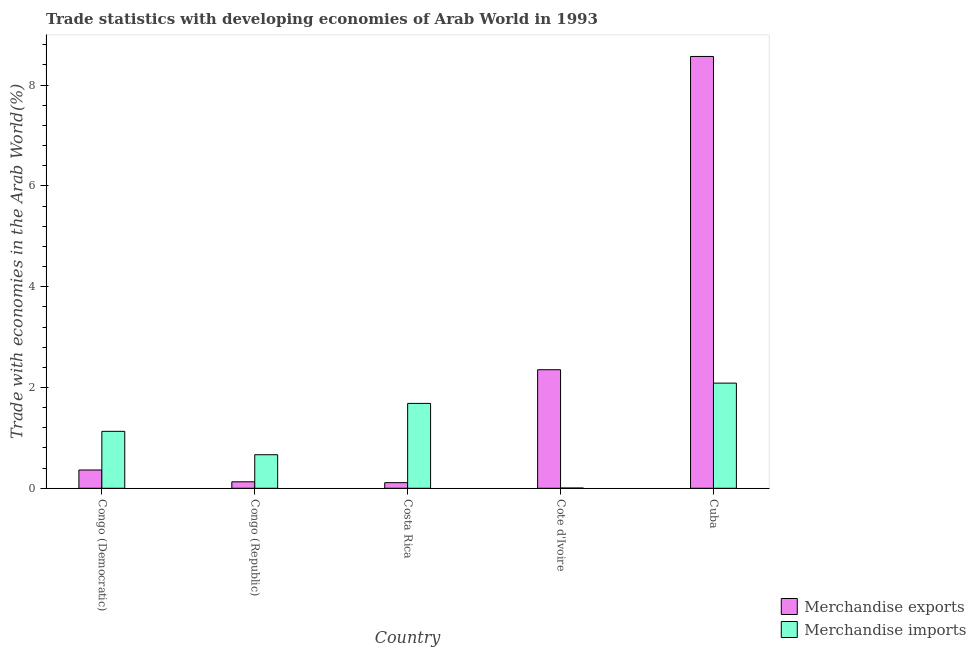How many different coloured bars are there?
Offer a terse response. 2. Are the number of bars per tick equal to the number of legend labels?
Provide a succinct answer. Yes. How many bars are there on the 4th tick from the left?
Make the answer very short. 2. What is the label of the 3rd group of bars from the left?
Offer a terse response. Costa Rica. In how many cases, is the number of bars for a given country not equal to the number of legend labels?
Offer a terse response. 0. What is the merchandise imports in Costa Rica?
Provide a succinct answer. 1.68. Across all countries, what is the maximum merchandise imports?
Offer a terse response. 2.09. Across all countries, what is the minimum merchandise imports?
Make the answer very short. 0.01. In which country was the merchandise exports maximum?
Ensure brevity in your answer.  Cuba. In which country was the merchandise imports minimum?
Your answer should be compact. Cote d'Ivoire. What is the total merchandise exports in the graph?
Your answer should be very brief. 11.52. What is the difference between the merchandise exports in Congo (Republic) and that in Cote d'Ivoire?
Your answer should be compact. -2.22. What is the difference between the merchandise exports in Cuba and the merchandise imports in Congo (Democratic)?
Your answer should be compact. 7.44. What is the average merchandise imports per country?
Provide a succinct answer. 1.11. What is the difference between the merchandise exports and merchandise imports in Costa Rica?
Provide a succinct answer. -1.57. In how many countries, is the merchandise imports greater than 6.8 %?
Make the answer very short. 0. What is the ratio of the merchandise exports in Congo (Democratic) to that in Cuba?
Provide a succinct answer. 0.04. Is the merchandise exports in Cote d'Ivoire less than that in Cuba?
Provide a succinct answer. Yes. Is the difference between the merchandise imports in Cote d'Ivoire and Cuba greater than the difference between the merchandise exports in Cote d'Ivoire and Cuba?
Give a very brief answer. Yes. What is the difference between the highest and the second highest merchandise imports?
Give a very brief answer. 0.4. What is the difference between the highest and the lowest merchandise exports?
Give a very brief answer. 8.46. In how many countries, is the merchandise exports greater than the average merchandise exports taken over all countries?
Ensure brevity in your answer.  2. Is the sum of the merchandise exports in Congo (Democratic) and Congo (Republic) greater than the maximum merchandise imports across all countries?
Ensure brevity in your answer.  No. What does the 2nd bar from the left in Congo (Democratic) represents?
Your response must be concise. Merchandise imports. How many countries are there in the graph?
Keep it short and to the point. 5. Does the graph contain grids?
Ensure brevity in your answer.  No. How many legend labels are there?
Offer a terse response. 2. What is the title of the graph?
Offer a very short reply. Trade statistics with developing economies of Arab World in 1993. What is the label or title of the X-axis?
Provide a succinct answer. Country. What is the label or title of the Y-axis?
Give a very brief answer. Trade with economies in the Arab World(%). What is the Trade with economies in the Arab World(%) of Merchandise exports in Congo (Democratic)?
Offer a terse response. 0.36. What is the Trade with economies in the Arab World(%) of Merchandise imports in Congo (Democratic)?
Keep it short and to the point. 1.13. What is the Trade with economies in the Arab World(%) of Merchandise exports in Congo (Republic)?
Ensure brevity in your answer.  0.13. What is the Trade with economies in the Arab World(%) in Merchandise imports in Congo (Republic)?
Provide a short and direct response. 0.67. What is the Trade with economies in the Arab World(%) in Merchandise exports in Costa Rica?
Offer a terse response. 0.11. What is the Trade with economies in the Arab World(%) of Merchandise imports in Costa Rica?
Keep it short and to the point. 1.68. What is the Trade with economies in the Arab World(%) of Merchandise exports in Cote d'Ivoire?
Your answer should be compact. 2.35. What is the Trade with economies in the Arab World(%) of Merchandise imports in Cote d'Ivoire?
Provide a short and direct response. 0.01. What is the Trade with economies in the Arab World(%) in Merchandise exports in Cuba?
Make the answer very short. 8.57. What is the Trade with economies in the Arab World(%) of Merchandise imports in Cuba?
Provide a succinct answer. 2.09. Across all countries, what is the maximum Trade with economies in the Arab World(%) of Merchandise exports?
Your answer should be compact. 8.57. Across all countries, what is the maximum Trade with economies in the Arab World(%) of Merchandise imports?
Ensure brevity in your answer.  2.09. Across all countries, what is the minimum Trade with economies in the Arab World(%) in Merchandise exports?
Your answer should be compact. 0.11. Across all countries, what is the minimum Trade with economies in the Arab World(%) of Merchandise imports?
Your response must be concise. 0.01. What is the total Trade with economies in the Arab World(%) of Merchandise exports in the graph?
Make the answer very short. 11.52. What is the total Trade with economies in the Arab World(%) of Merchandise imports in the graph?
Give a very brief answer. 5.57. What is the difference between the Trade with economies in the Arab World(%) in Merchandise exports in Congo (Democratic) and that in Congo (Republic)?
Offer a very short reply. 0.23. What is the difference between the Trade with economies in the Arab World(%) of Merchandise imports in Congo (Democratic) and that in Congo (Republic)?
Your response must be concise. 0.46. What is the difference between the Trade with economies in the Arab World(%) in Merchandise exports in Congo (Democratic) and that in Costa Rica?
Your answer should be very brief. 0.25. What is the difference between the Trade with economies in the Arab World(%) in Merchandise imports in Congo (Democratic) and that in Costa Rica?
Offer a very short reply. -0.55. What is the difference between the Trade with economies in the Arab World(%) in Merchandise exports in Congo (Democratic) and that in Cote d'Ivoire?
Your answer should be very brief. -1.99. What is the difference between the Trade with economies in the Arab World(%) in Merchandise imports in Congo (Democratic) and that in Cote d'Ivoire?
Your response must be concise. 1.12. What is the difference between the Trade with economies in the Arab World(%) of Merchandise exports in Congo (Democratic) and that in Cuba?
Provide a short and direct response. -8.2. What is the difference between the Trade with economies in the Arab World(%) in Merchandise imports in Congo (Democratic) and that in Cuba?
Ensure brevity in your answer.  -0.96. What is the difference between the Trade with economies in the Arab World(%) in Merchandise exports in Congo (Republic) and that in Costa Rica?
Your response must be concise. 0.02. What is the difference between the Trade with economies in the Arab World(%) of Merchandise imports in Congo (Republic) and that in Costa Rica?
Offer a very short reply. -1.02. What is the difference between the Trade with economies in the Arab World(%) of Merchandise exports in Congo (Republic) and that in Cote d'Ivoire?
Your response must be concise. -2.22. What is the difference between the Trade with economies in the Arab World(%) of Merchandise imports in Congo (Republic) and that in Cote d'Ivoire?
Your answer should be very brief. 0.66. What is the difference between the Trade with economies in the Arab World(%) in Merchandise exports in Congo (Republic) and that in Cuba?
Provide a short and direct response. -8.44. What is the difference between the Trade with economies in the Arab World(%) of Merchandise imports in Congo (Republic) and that in Cuba?
Give a very brief answer. -1.42. What is the difference between the Trade with economies in the Arab World(%) in Merchandise exports in Costa Rica and that in Cote d'Ivoire?
Provide a succinct answer. -2.24. What is the difference between the Trade with economies in the Arab World(%) of Merchandise imports in Costa Rica and that in Cote d'Ivoire?
Provide a succinct answer. 1.68. What is the difference between the Trade with economies in the Arab World(%) of Merchandise exports in Costa Rica and that in Cuba?
Ensure brevity in your answer.  -8.46. What is the difference between the Trade with economies in the Arab World(%) of Merchandise imports in Costa Rica and that in Cuba?
Keep it short and to the point. -0.4. What is the difference between the Trade with economies in the Arab World(%) in Merchandise exports in Cote d'Ivoire and that in Cuba?
Provide a short and direct response. -6.22. What is the difference between the Trade with economies in the Arab World(%) of Merchandise imports in Cote d'Ivoire and that in Cuba?
Provide a short and direct response. -2.08. What is the difference between the Trade with economies in the Arab World(%) of Merchandise exports in Congo (Democratic) and the Trade with economies in the Arab World(%) of Merchandise imports in Congo (Republic)?
Keep it short and to the point. -0.3. What is the difference between the Trade with economies in the Arab World(%) in Merchandise exports in Congo (Democratic) and the Trade with economies in the Arab World(%) in Merchandise imports in Costa Rica?
Provide a succinct answer. -1.32. What is the difference between the Trade with economies in the Arab World(%) of Merchandise exports in Congo (Democratic) and the Trade with economies in the Arab World(%) of Merchandise imports in Cote d'Ivoire?
Provide a short and direct response. 0.36. What is the difference between the Trade with economies in the Arab World(%) in Merchandise exports in Congo (Democratic) and the Trade with economies in the Arab World(%) in Merchandise imports in Cuba?
Keep it short and to the point. -1.72. What is the difference between the Trade with economies in the Arab World(%) in Merchandise exports in Congo (Republic) and the Trade with economies in the Arab World(%) in Merchandise imports in Costa Rica?
Give a very brief answer. -1.56. What is the difference between the Trade with economies in the Arab World(%) of Merchandise exports in Congo (Republic) and the Trade with economies in the Arab World(%) of Merchandise imports in Cote d'Ivoire?
Ensure brevity in your answer.  0.12. What is the difference between the Trade with economies in the Arab World(%) of Merchandise exports in Congo (Republic) and the Trade with economies in the Arab World(%) of Merchandise imports in Cuba?
Your response must be concise. -1.96. What is the difference between the Trade with economies in the Arab World(%) of Merchandise exports in Costa Rica and the Trade with economies in the Arab World(%) of Merchandise imports in Cote d'Ivoire?
Ensure brevity in your answer.  0.11. What is the difference between the Trade with economies in the Arab World(%) of Merchandise exports in Costa Rica and the Trade with economies in the Arab World(%) of Merchandise imports in Cuba?
Offer a terse response. -1.98. What is the difference between the Trade with economies in the Arab World(%) in Merchandise exports in Cote d'Ivoire and the Trade with economies in the Arab World(%) in Merchandise imports in Cuba?
Ensure brevity in your answer.  0.27. What is the average Trade with economies in the Arab World(%) of Merchandise exports per country?
Your answer should be compact. 2.3. What is the average Trade with economies in the Arab World(%) in Merchandise imports per country?
Make the answer very short. 1.11. What is the difference between the Trade with economies in the Arab World(%) in Merchandise exports and Trade with economies in the Arab World(%) in Merchandise imports in Congo (Democratic)?
Offer a terse response. -0.77. What is the difference between the Trade with economies in the Arab World(%) of Merchandise exports and Trade with economies in the Arab World(%) of Merchandise imports in Congo (Republic)?
Your answer should be very brief. -0.54. What is the difference between the Trade with economies in the Arab World(%) in Merchandise exports and Trade with economies in the Arab World(%) in Merchandise imports in Costa Rica?
Offer a terse response. -1.57. What is the difference between the Trade with economies in the Arab World(%) of Merchandise exports and Trade with economies in the Arab World(%) of Merchandise imports in Cote d'Ivoire?
Provide a succinct answer. 2.35. What is the difference between the Trade with economies in the Arab World(%) of Merchandise exports and Trade with economies in the Arab World(%) of Merchandise imports in Cuba?
Your answer should be compact. 6.48. What is the ratio of the Trade with economies in the Arab World(%) in Merchandise exports in Congo (Democratic) to that in Congo (Republic)?
Make the answer very short. 2.82. What is the ratio of the Trade with economies in the Arab World(%) of Merchandise imports in Congo (Democratic) to that in Congo (Republic)?
Your answer should be compact. 1.7. What is the ratio of the Trade with economies in the Arab World(%) in Merchandise exports in Congo (Democratic) to that in Costa Rica?
Keep it short and to the point. 3.26. What is the ratio of the Trade with economies in the Arab World(%) in Merchandise imports in Congo (Democratic) to that in Costa Rica?
Give a very brief answer. 0.67. What is the ratio of the Trade with economies in the Arab World(%) of Merchandise exports in Congo (Democratic) to that in Cote d'Ivoire?
Provide a short and direct response. 0.15. What is the ratio of the Trade with economies in the Arab World(%) of Merchandise imports in Congo (Democratic) to that in Cote d'Ivoire?
Ensure brevity in your answer.  218.74. What is the ratio of the Trade with economies in the Arab World(%) in Merchandise exports in Congo (Democratic) to that in Cuba?
Ensure brevity in your answer.  0.04. What is the ratio of the Trade with economies in the Arab World(%) of Merchandise imports in Congo (Democratic) to that in Cuba?
Provide a short and direct response. 0.54. What is the ratio of the Trade with economies in the Arab World(%) in Merchandise exports in Congo (Republic) to that in Costa Rica?
Your response must be concise. 1.16. What is the ratio of the Trade with economies in the Arab World(%) in Merchandise imports in Congo (Republic) to that in Costa Rica?
Offer a very short reply. 0.4. What is the ratio of the Trade with economies in the Arab World(%) in Merchandise exports in Congo (Republic) to that in Cote d'Ivoire?
Provide a short and direct response. 0.05. What is the ratio of the Trade with economies in the Arab World(%) of Merchandise imports in Congo (Republic) to that in Cote d'Ivoire?
Offer a very short reply. 128.9. What is the ratio of the Trade with economies in the Arab World(%) of Merchandise exports in Congo (Republic) to that in Cuba?
Ensure brevity in your answer.  0.01. What is the ratio of the Trade with economies in the Arab World(%) in Merchandise imports in Congo (Republic) to that in Cuba?
Provide a succinct answer. 0.32. What is the ratio of the Trade with economies in the Arab World(%) in Merchandise exports in Costa Rica to that in Cote d'Ivoire?
Provide a short and direct response. 0.05. What is the ratio of the Trade with economies in the Arab World(%) of Merchandise imports in Costa Rica to that in Cote d'Ivoire?
Your response must be concise. 326.09. What is the ratio of the Trade with economies in the Arab World(%) of Merchandise exports in Costa Rica to that in Cuba?
Keep it short and to the point. 0.01. What is the ratio of the Trade with economies in the Arab World(%) in Merchandise imports in Costa Rica to that in Cuba?
Your response must be concise. 0.81. What is the ratio of the Trade with economies in the Arab World(%) in Merchandise exports in Cote d'Ivoire to that in Cuba?
Your answer should be very brief. 0.27. What is the ratio of the Trade with economies in the Arab World(%) in Merchandise imports in Cote d'Ivoire to that in Cuba?
Make the answer very short. 0. What is the difference between the highest and the second highest Trade with economies in the Arab World(%) of Merchandise exports?
Provide a short and direct response. 6.22. What is the difference between the highest and the second highest Trade with economies in the Arab World(%) in Merchandise imports?
Offer a very short reply. 0.4. What is the difference between the highest and the lowest Trade with economies in the Arab World(%) in Merchandise exports?
Offer a terse response. 8.46. What is the difference between the highest and the lowest Trade with economies in the Arab World(%) in Merchandise imports?
Offer a very short reply. 2.08. 